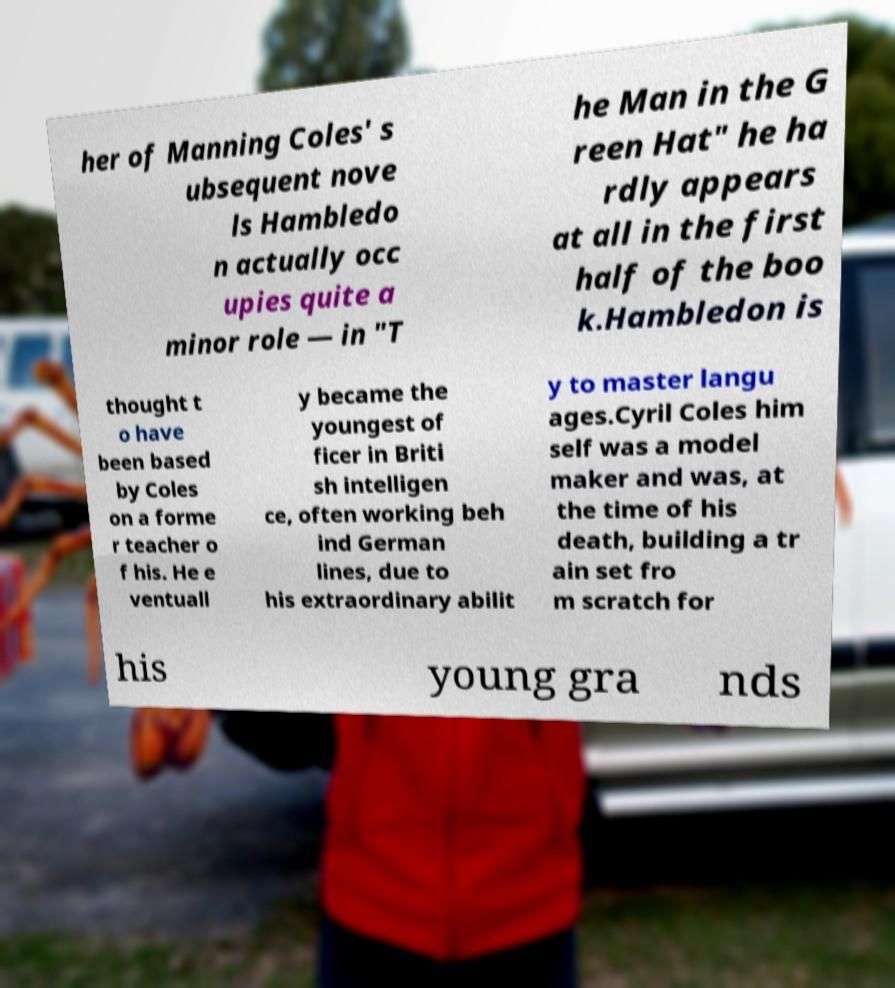Could you assist in decoding the text presented in this image and type it out clearly? her of Manning Coles' s ubsequent nove ls Hambledo n actually occ upies quite a minor role — in "T he Man in the G reen Hat" he ha rdly appears at all in the first half of the boo k.Hambledon is thought t o have been based by Coles on a forme r teacher o f his. He e ventuall y became the youngest of ficer in Briti sh intelligen ce, often working beh ind German lines, due to his extraordinary abilit y to master langu ages.Cyril Coles him self was a model maker and was, at the time of his death, building a tr ain set fro m scratch for his young gra nds 